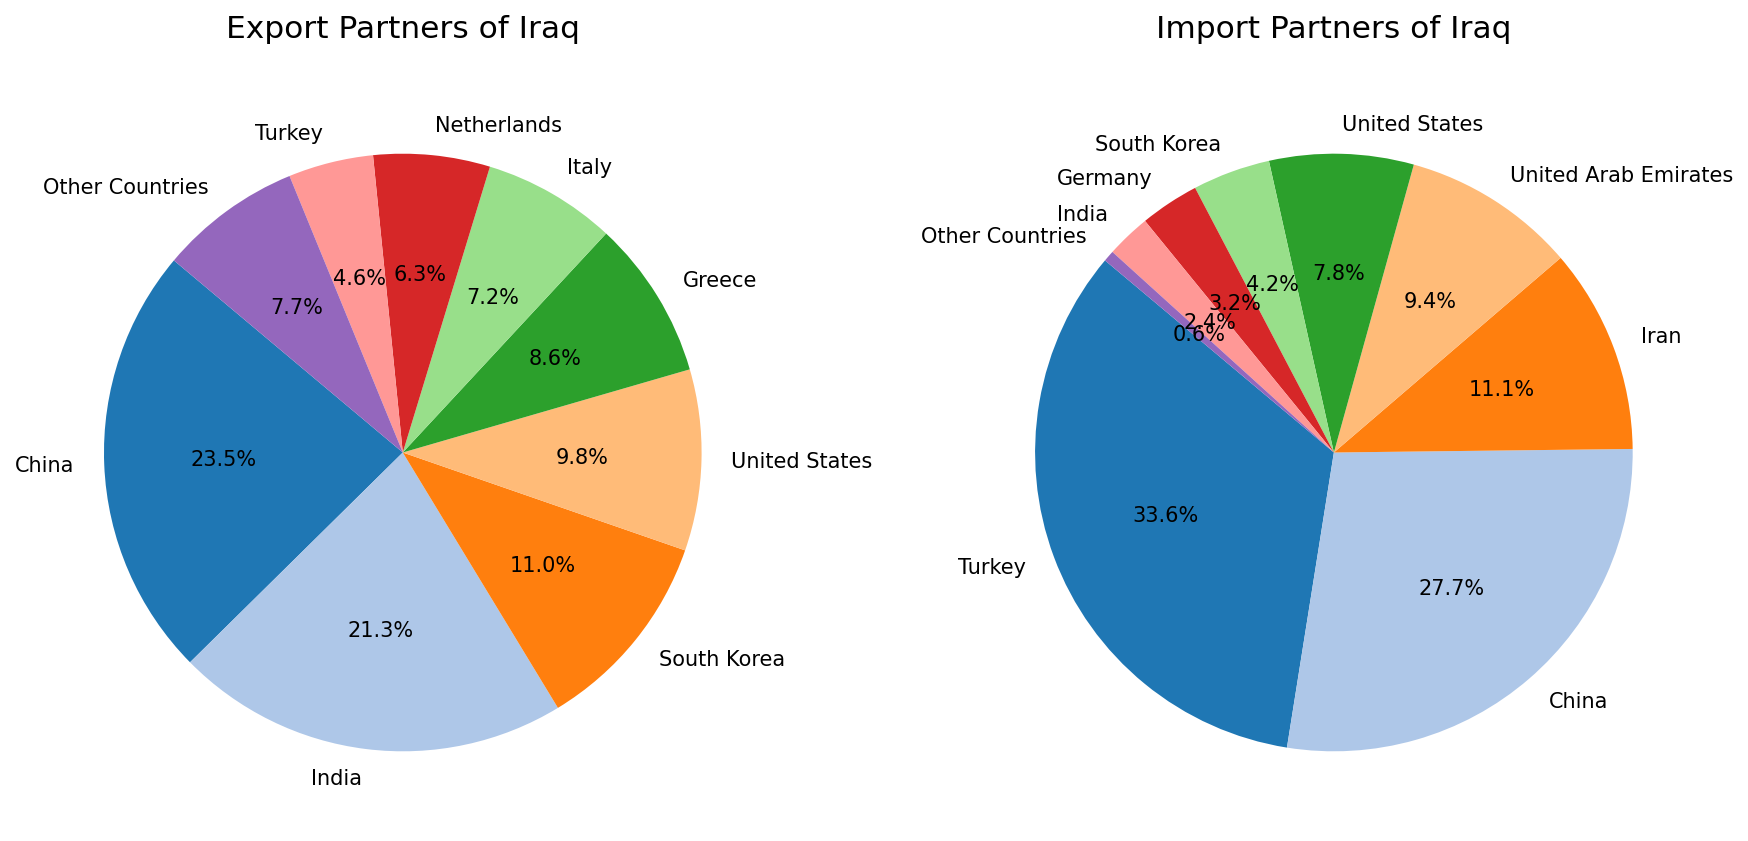What is the combined percentage of Iraq's exports to China and India? From the export partners, China has 23.5% and India has 21.3%. Adding these percentages together gives 23.5 + 21.3 = 44.8%.
Answer: 44.8% Which country is the largest export partner for Iraq? By visually inspecting the pie chart for export partners, the largest segment is labeled as China with a percentage of 23.5%.
Answer: China Does Turkey have a higher percentage as an import partner or export partner for Iraq? In the export partners' pie chart, Turkey is at 4.6%, whereas in the import partners' pie chart, Turkey is at 33.6%. Thus, Turkey has a higher percentage as an import partner.
Answer: Import Partner What is the difference in percentage between the largest import partner and the largest export partner of Iraq? The largest import partner is Turkey at 33.6%, and the largest export partner is China at 23.5%. The difference is 33.6 - 23.5 = 10.1%.
Answer: 10.1% Who is the third-largest import partner of Iraq and what is their percentage? In the import partners' pie chart, the third-largest segment is labeled as Iran with a percentage of 11.1%.
Answer: Iran (11.1%) Among the labeled countries, which export and import partner shares the same percentage, and what is that percentage? From the pie charts, the United States appears in both export and import partners. In the export partners, the United States has 9.8%, and in the import partners, it has 7.8%. Thus, they do not share the same percentage. No other country on both lists shares the same percentage.
Answer: None Which country has a smaller share as an import partner compared to its share as an export partner for Iraq? By comparing the countries in both pie charts, India is the only country with a smaller percentage as an import partner (2.4%) compared to its export partner percentage (21.3%).
Answer: India What is the total percentage for other countries in both import and export partners combined? The percentage for other countries in export partners is 7.7%, and in import partners, it is 0.6%. The combined total is 7.7 + 0.6 = 8.3%.
Answer: 8.3% How many countries have a higher percentage as export partners compared to the United States' import percentage (7.8%)? For export partners, the countries with a percentage higher than 7.8% are China (23.5%), India (21.3%), South Korea (11.0%), and Greece (8.6%). This counts as four countries.
Answer: Four What is the sum of the percentages of Iraq's export partners who have a larger share than Italy? For export partners, Italy has 7.2%. The countries with a larger share are China (23.5%), India (21.3%), South Korea (11.0%), United States (9.8%), and Greece (8.6%). Their combined percentage is 23.5 + 21.3 + 11.0 + 9.8 + 8.6 = 74.2%.
Answer: 74.2% 